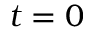Convert formula to latex. <formula><loc_0><loc_0><loc_500><loc_500>t = 0</formula> 